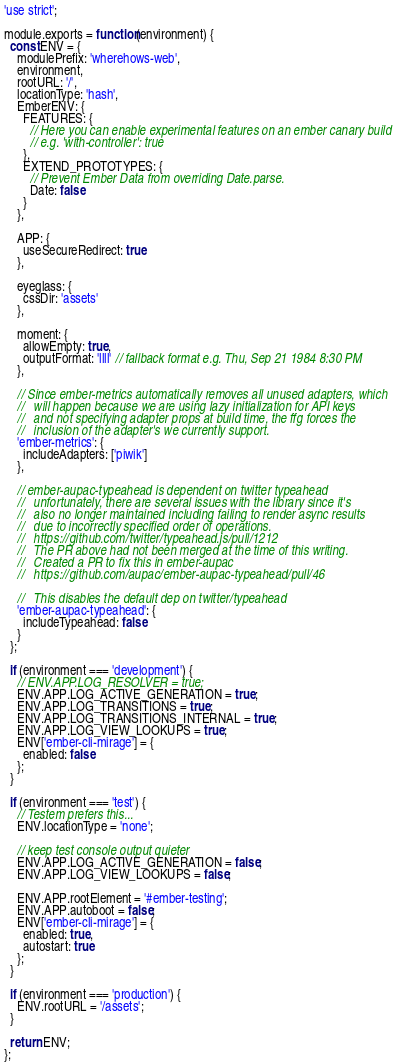<code> <loc_0><loc_0><loc_500><loc_500><_JavaScript_>'use strict';

module.exports = function(environment) {
  const ENV = {
    modulePrefix: 'wherehows-web',
    environment,
    rootURL: '/',
    locationType: 'hash',
    EmberENV: {
      FEATURES: {
        // Here you can enable experimental features on an ember canary build
        // e.g. 'with-controller': true
      },
      EXTEND_PROTOTYPES: {
        // Prevent Ember Data from overriding Date.parse.
        Date: false
      }
    },

    APP: {
      useSecureRedirect: true
    },

    eyeglass: {
      cssDir: 'assets'
    },

    moment: {
      allowEmpty: true,
      outputFormat: 'llll' // fallback format e.g. Thu, Sep 21 1984 8:30 PM
    },

    // Since ember-metrics automatically removes all unused adapters, which
    //   will happen because we are using lazy initialization for API keys
    //   and not specifying adapter props at build time, the ffg forces the
    //   inclusion of the adapter's we currently support.
    'ember-metrics': {
      includeAdapters: ['piwik']
    },

    // ember-aupac-typeahead is dependent on twitter typeahead
    //   unfortunately, there are several issues with the library since it's
    //   also no longer maintained including failing to render async results
    //   due to incorrectly specified order of operations.
    //   https://github.com/twitter/typeahead.js/pull/1212
    //   The PR above had not been merged at the time of this writing.
    //   Created a PR to fix this in ember-aupac
    //   https://github.com/aupac/ember-aupac-typeahead/pull/46

    //   This disables the default dep on twitter/typeahead
    'ember-aupac-typeahead': {
      includeTypeahead: false
    }
  };

  if (environment === 'development') {
    // ENV.APP.LOG_RESOLVER = true;
    ENV.APP.LOG_ACTIVE_GENERATION = true;
    ENV.APP.LOG_TRANSITIONS = true;
    ENV.APP.LOG_TRANSITIONS_INTERNAL = true;
    ENV.APP.LOG_VIEW_LOOKUPS = true;
    ENV['ember-cli-mirage'] = {
      enabled: false
    };
  }

  if (environment === 'test') {
    // Testem prefers this...
    ENV.locationType = 'none';

    // keep test console output quieter
    ENV.APP.LOG_ACTIVE_GENERATION = false;
    ENV.APP.LOG_VIEW_LOOKUPS = false;

    ENV.APP.rootElement = '#ember-testing';
    ENV.APP.autoboot = false;
    ENV['ember-cli-mirage'] = {
      enabled: true,
      autostart: true
    };
  }

  if (environment === 'production') {
    ENV.rootURL = '/assets';
  }

  return ENV;
};
</code> 